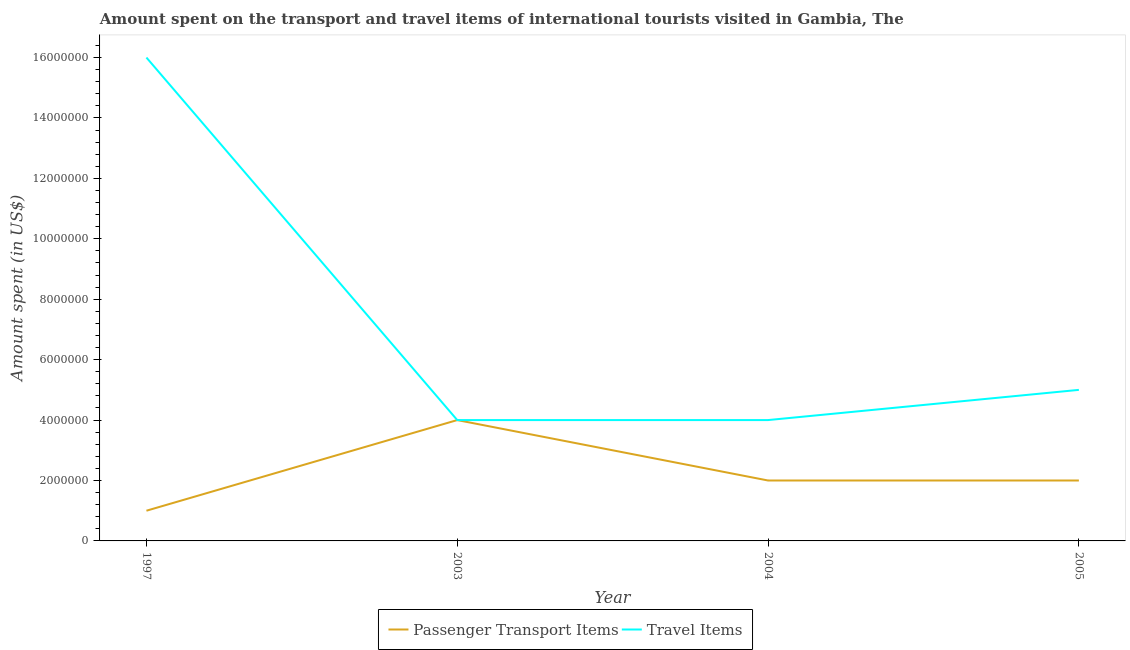Does the line corresponding to amount spent on passenger transport items intersect with the line corresponding to amount spent in travel items?
Provide a short and direct response. Yes. Is the number of lines equal to the number of legend labels?
Your answer should be compact. Yes. What is the amount spent on passenger transport items in 2003?
Ensure brevity in your answer.  4.00e+06. Across all years, what is the maximum amount spent on passenger transport items?
Your response must be concise. 4.00e+06. Across all years, what is the minimum amount spent on passenger transport items?
Your response must be concise. 1.00e+06. In which year was the amount spent in travel items maximum?
Your response must be concise. 1997. In which year was the amount spent on passenger transport items minimum?
Provide a succinct answer. 1997. What is the total amount spent on passenger transport items in the graph?
Give a very brief answer. 9.00e+06. What is the difference between the amount spent in travel items in 1997 and that in 2004?
Provide a succinct answer. 1.20e+07. What is the difference between the amount spent in travel items in 2004 and the amount spent on passenger transport items in 1997?
Your response must be concise. 3.00e+06. What is the average amount spent in travel items per year?
Ensure brevity in your answer.  7.25e+06. In the year 2003, what is the difference between the amount spent in travel items and amount spent on passenger transport items?
Give a very brief answer. 0. In how many years, is the amount spent on passenger transport items greater than 1200000 US$?
Ensure brevity in your answer.  3. What is the ratio of the amount spent in travel items in 1997 to that in 2004?
Provide a short and direct response. 4. Is the amount spent in travel items in 1997 less than that in 2004?
Offer a very short reply. No. What is the difference between the highest and the second highest amount spent in travel items?
Make the answer very short. 1.10e+07. What is the difference between the highest and the lowest amount spent on passenger transport items?
Your response must be concise. 3.00e+06. In how many years, is the amount spent on passenger transport items greater than the average amount spent on passenger transport items taken over all years?
Offer a very short reply. 1. Is the sum of the amount spent in travel items in 2003 and 2005 greater than the maximum amount spent on passenger transport items across all years?
Provide a succinct answer. Yes. Does the amount spent in travel items monotonically increase over the years?
Offer a very short reply. No. Is the amount spent in travel items strictly less than the amount spent on passenger transport items over the years?
Provide a short and direct response. No. How many years are there in the graph?
Give a very brief answer. 4. What is the difference between two consecutive major ticks on the Y-axis?
Your answer should be compact. 2.00e+06. Are the values on the major ticks of Y-axis written in scientific E-notation?
Ensure brevity in your answer.  No. Where does the legend appear in the graph?
Your answer should be compact. Bottom center. How many legend labels are there?
Your answer should be compact. 2. What is the title of the graph?
Your answer should be compact. Amount spent on the transport and travel items of international tourists visited in Gambia, The. Does "Non-pregnant women" appear as one of the legend labels in the graph?
Your response must be concise. No. What is the label or title of the Y-axis?
Provide a succinct answer. Amount spent (in US$). What is the Amount spent (in US$) in Passenger Transport Items in 1997?
Ensure brevity in your answer.  1.00e+06. What is the Amount spent (in US$) of Travel Items in 1997?
Make the answer very short. 1.60e+07. What is the Amount spent (in US$) of Travel Items in 2003?
Provide a short and direct response. 4.00e+06. What is the Amount spent (in US$) in Passenger Transport Items in 2004?
Provide a short and direct response. 2.00e+06. What is the Amount spent (in US$) of Travel Items in 2005?
Ensure brevity in your answer.  5.00e+06. Across all years, what is the maximum Amount spent (in US$) in Passenger Transport Items?
Your response must be concise. 4.00e+06. Across all years, what is the maximum Amount spent (in US$) in Travel Items?
Make the answer very short. 1.60e+07. Across all years, what is the minimum Amount spent (in US$) of Travel Items?
Provide a succinct answer. 4.00e+06. What is the total Amount spent (in US$) of Passenger Transport Items in the graph?
Ensure brevity in your answer.  9.00e+06. What is the total Amount spent (in US$) in Travel Items in the graph?
Provide a short and direct response. 2.90e+07. What is the difference between the Amount spent (in US$) of Passenger Transport Items in 1997 and that in 2004?
Ensure brevity in your answer.  -1.00e+06. What is the difference between the Amount spent (in US$) of Passenger Transport Items in 1997 and that in 2005?
Make the answer very short. -1.00e+06. What is the difference between the Amount spent (in US$) in Travel Items in 1997 and that in 2005?
Offer a terse response. 1.10e+07. What is the difference between the Amount spent (in US$) of Passenger Transport Items in 2003 and that in 2004?
Give a very brief answer. 2.00e+06. What is the difference between the Amount spent (in US$) in Passenger Transport Items in 2003 and that in 2005?
Keep it short and to the point. 2.00e+06. What is the difference between the Amount spent (in US$) of Travel Items in 2003 and that in 2005?
Your answer should be very brief. -1.00e+06. What is the difference between the Amount spent (in US$) of Travel Items in 2004 and that in 2005?
Your answer should be very brief. -1.00e+06. What is the difference between the Amount spent (in US$) in Passenger Transport Items in 1997 and the Amount spent (in US$) in Travel Items in 2004?
Your answer should be compact. -3.00e+06. What is the difference between the Amount spent (in US$) in Passenger Transport Items in 2003 and the Amount spent (in US$) in Travel Items in 2004?
Make the answer very short. 0. What is the average Amount spent (in US$) in Passenger Transport Items per year?
Give a very brief answer. 2.25e+06. What is the average Amount spent (in US$) in Travel Items per year?
Keep it short and to the point. 7.25e+06. In the year 1997, what is the difference between the Amount spent (in US$) in Passenger Transport Items and Amount spent (in US$) in Travel Items?
Keep it short and to the point. -1.50e+07. In the year 2003, what is the difference between the Amount spent (in US$) of Passenger Transport Items and Amount spent (in US$) of Travel Items?
Your response must be concise. 0. In the year 2004, what is the difference between the Amount spent (in US$) of Passenger Transport Items and Amount spent (in US$) of Travel Items?
Ensure brevity in your answer.  -2.00e+06. In the year 2005, what is the difference between the Amount spent (in US$) in Passenger Transport Items and Amount spent (in US$) in Travel Items?
Your response must be concise. -3.00e+06. What is the ratio of the Amount spent (in US$) of Passenger Transport Items in 1997 to that in 2004?
Give a very brief answer. 0.5. What is the ratio of the Amount spent (in US$) in Travel Items in 1997 to that in 2004?
Give a very brief answer. 4. What is the ratio of the Amount spent (in US$) in Travel Items in 1997 to that in 2005?
Ensure brevity in your answer.  3.2. What is the ratio of the Amount spent (in US$) in Passenger Transport Items in 2003 to that in 2004?
Provide a short and direct response. 2. What is the ratio of the Amount spent (in US$) in Travel Items in 2003 to that in 2004?
Your answer should be very brief. 1. What is the ratio of the Amount spent (in US$) of Passenger Transport Items in 2003 to that in 2005?
Give a very brief answer. 2. What is the ratio of the Amount spent (in US$) of Travel Items in 2003 to that in 2005?
Give a very brief answer. 0.8. What is the ratio of the Amount spent (in US$) in Passenger Transport Items in 2004 to that in 2005?
Provide a short and direct response. 1. What is the difference between the highest and the second highest Amount spent (in US$) in Passenger Transport Items?
Provide a succinct answer. 2.00e+06. What is the difference between the highest and the second highest Amount spent (in US$) in Travel Items?
Give a very brief answer. 1.10e+07. What is the difference between the highest and the lowest Amount spent (in US$) of Passenger Transport Items?
Give a very brief answer. 3.00e+06. What is the difference between the highest and the lowest Amount spent (in US$) in Travel Items?
Your response must be concise. 1.20e+07. 